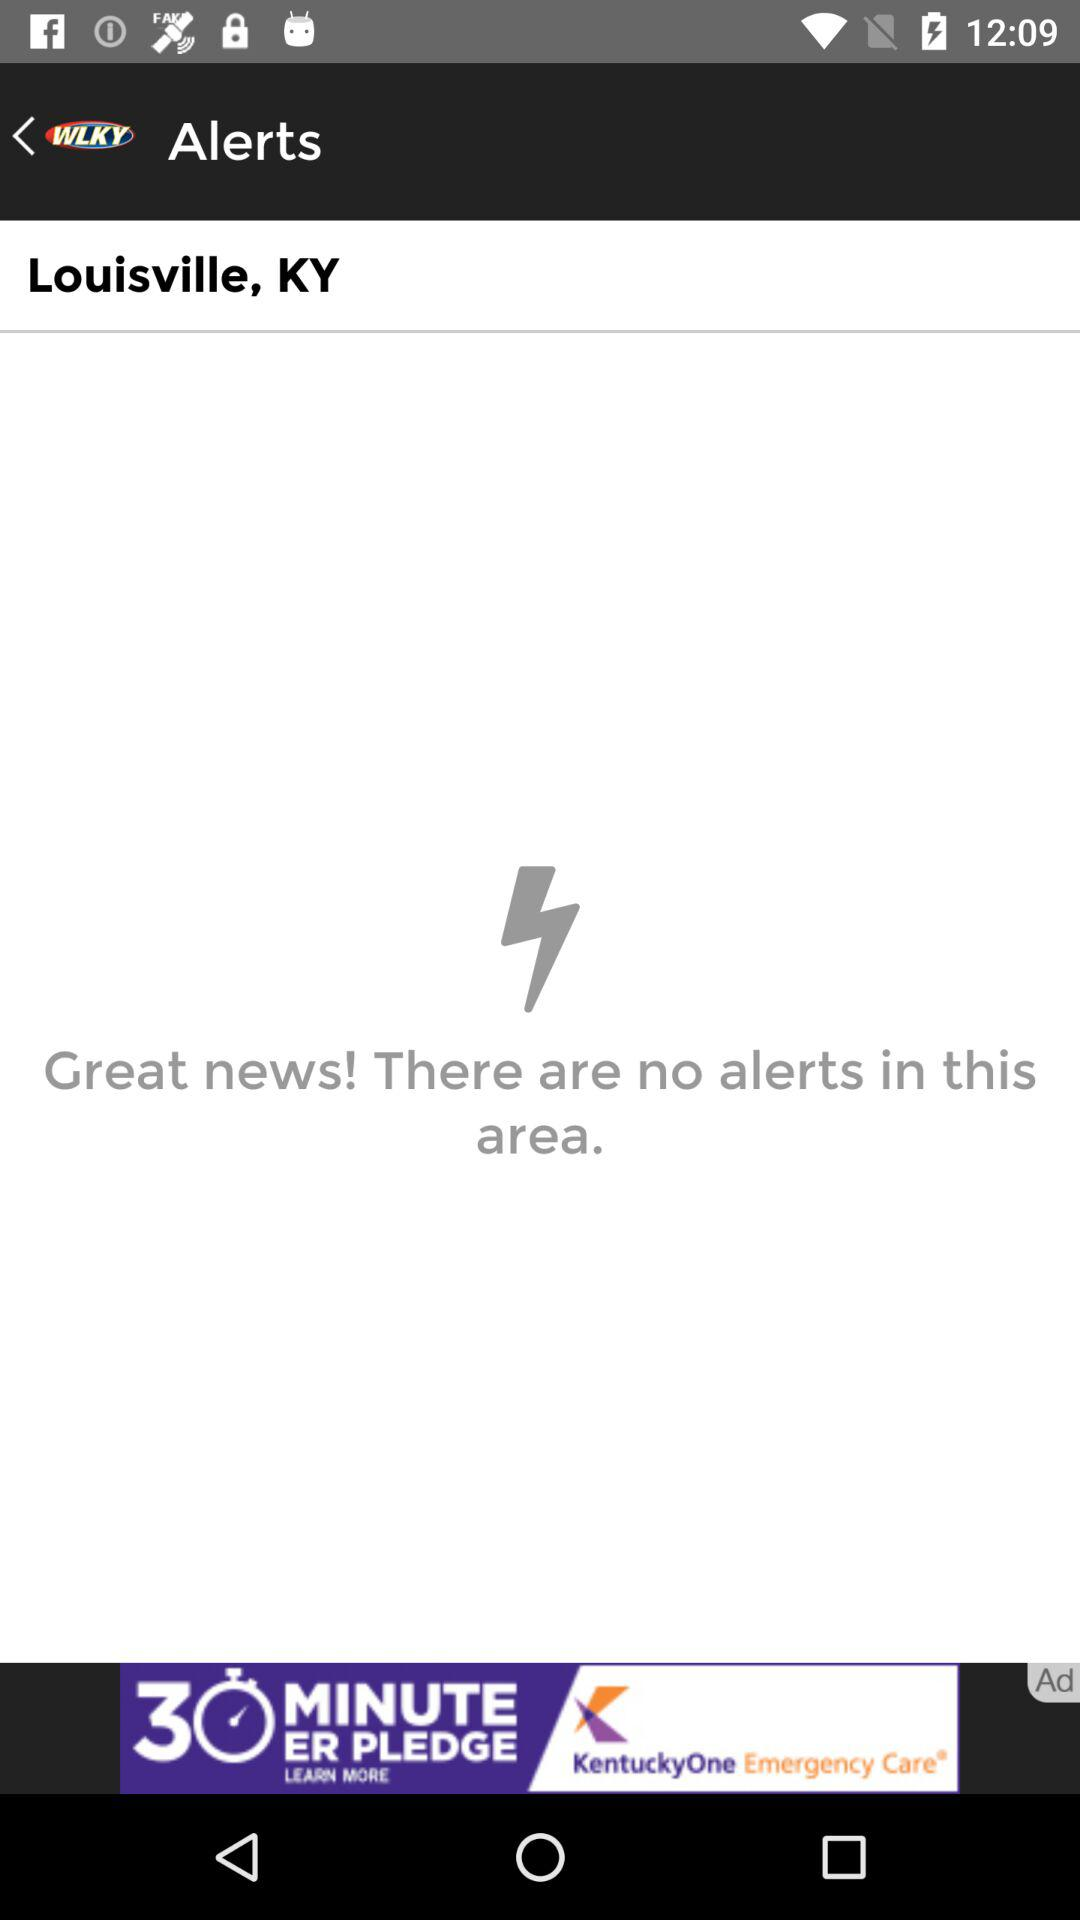What is the location? The location is Louisville, KY. 